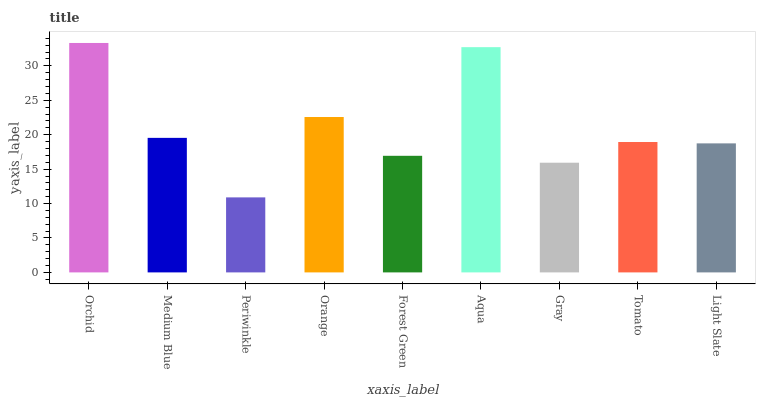Is Periwinkle the minimum?
Answer yes or no. Yes. Is Orchid the maximum?
Answer yes or no. Yes. Is Medium Blue the minimum?
Answer yes or no. No. Is Medium Blue the maximum?
Answer yes or no. No. Is Orchid greater than Medium Blue?
Answer yes or no. Yes. Is Medium Blue less than Orchid?
Answer yes or no. Yes. Is Medium Blue greater than Orchid?
Answer yes or no. No. Is Orchid less than Medium Blue?
Answer yes or no. No. Is Tomato the high median?
Answer yes or no. Yes. Is Tomato the low median?
Answer yes or no. Yes. Is Gray the high median?
Answer yes or no. No. Is Periwinkle the low median?
Answer yes or no. No. 